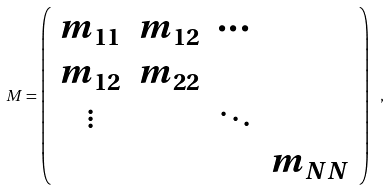<formula> <loc_0><loc_0><loc_500><loc_500>M = \left ( \begin{array} { c c c c } m _ { 1 1 } & m _ { 1 2 } & \cdots & \\ m _ { 1 2 } & m _ { 2 2 } & & \\ \vdots & & \ddots & \\ & & & m _ { N N } \end{array} \right ) \ ,</formula> 